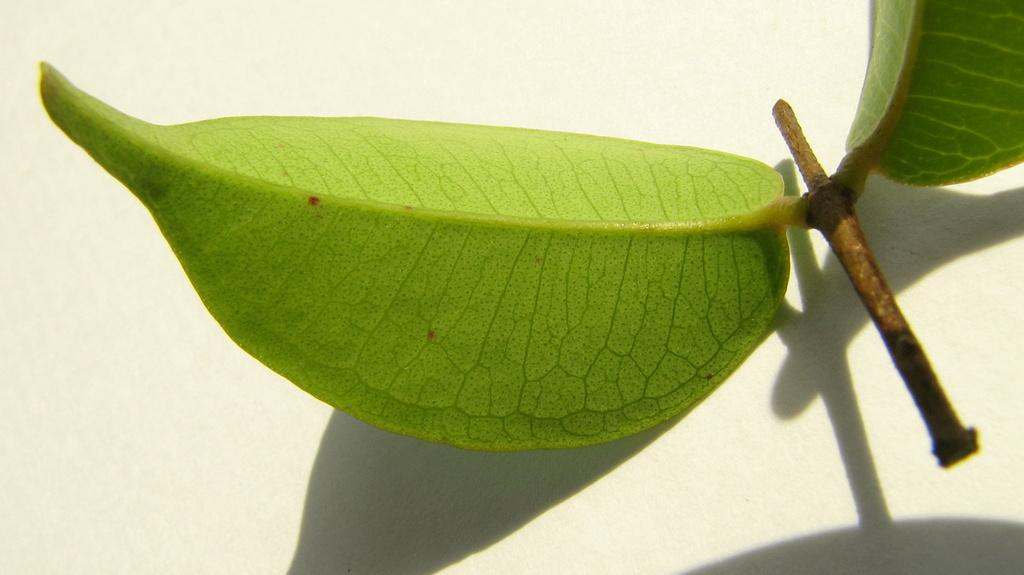What is the main object in the image? The main object in the image is a small stem. What is attached to the stem? The stem has two green leaves. Where is the stem and leaves located? The stem and leaves are on a surface. What type of pest can be seen crawling on the stem in the image? There is no pest visible in the image; it only shows a small stem with two green leaves on a surface. 